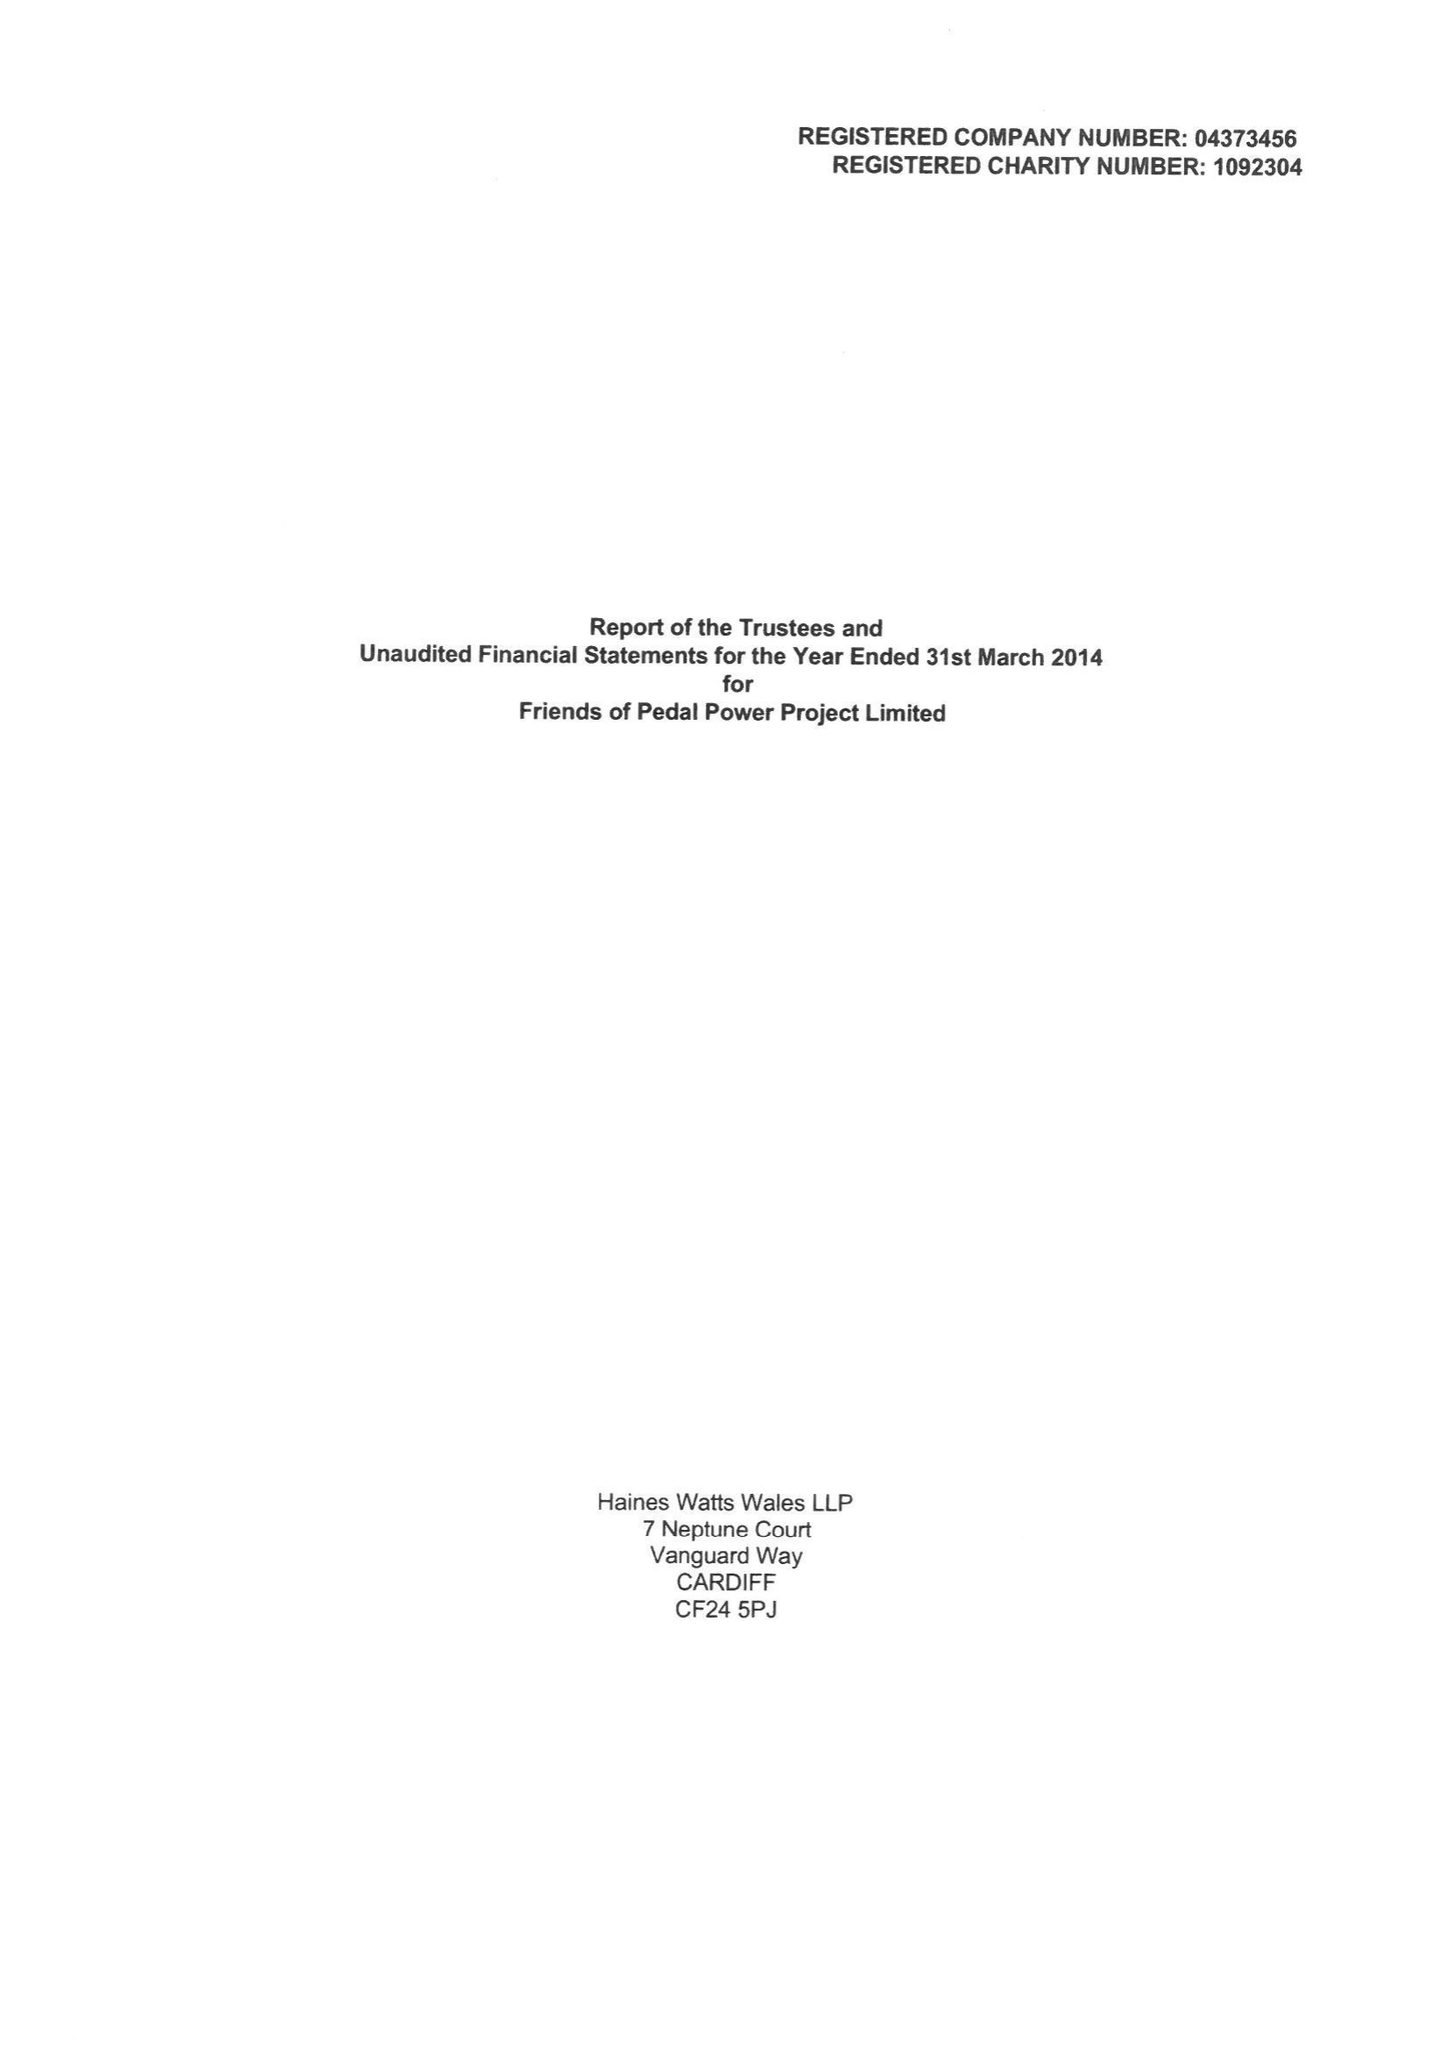What is the value for the spending_annually_in_british_pounds?
Answer the question using a single word or phrase. 298922.00 